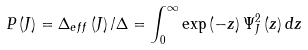<formula> <loc_0><loc_0><loc_500><loc_500>P \left ( J \right ) = \Delta _ { e f f } \left ( J \right ) / \Delta = \int _ { 0 } ^ { \infty } \exp \left ( - z \right ) \Psi _ { J } ^ { 2 } \left ( z \right ) d z</formula> 